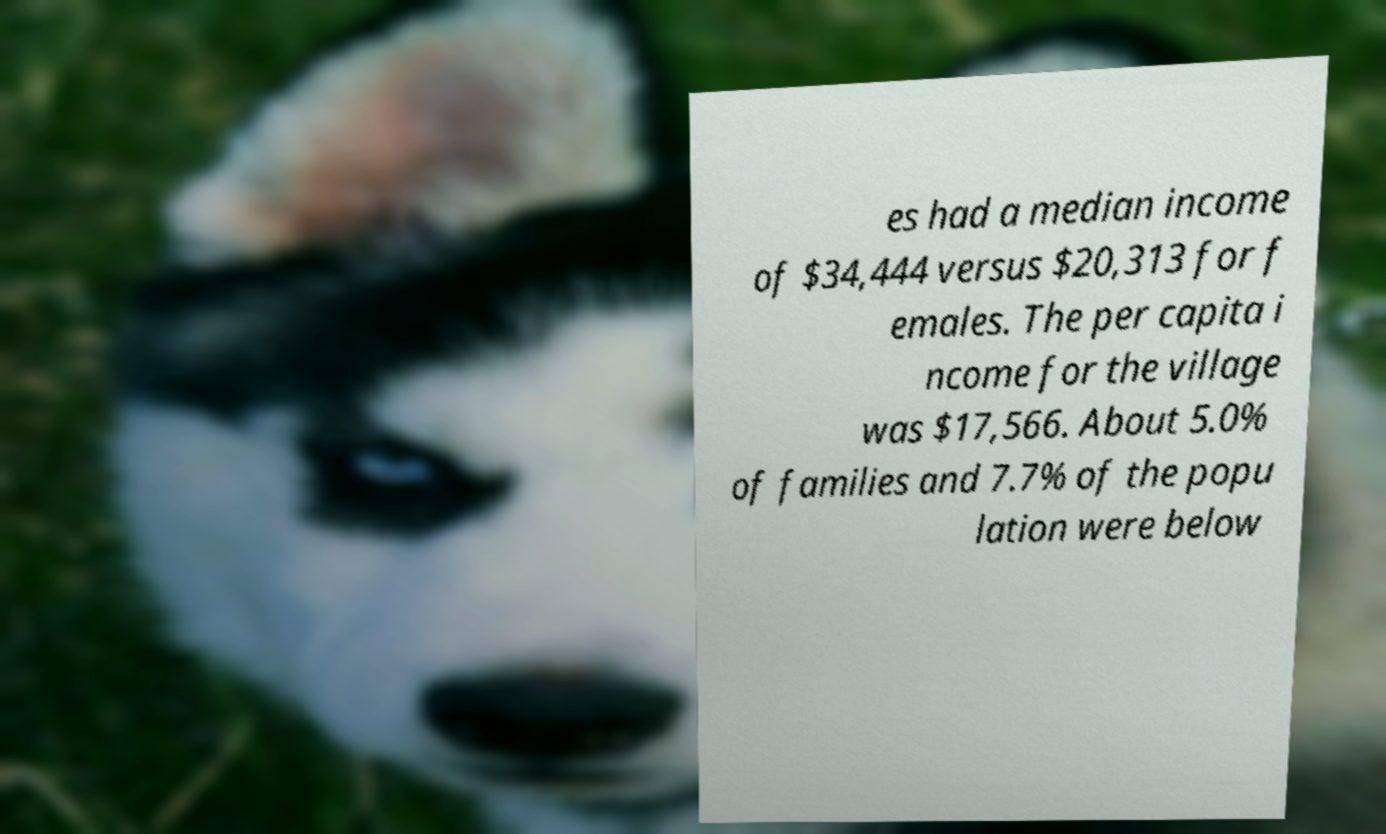I need the written content from this picture converted into text. Can you do that? es had a median income of $34,444 versus $20,313 for f emales. The per capita i ncome for the village was $17,566. About 5.0% of families and 7.7% of the popu lation were below 